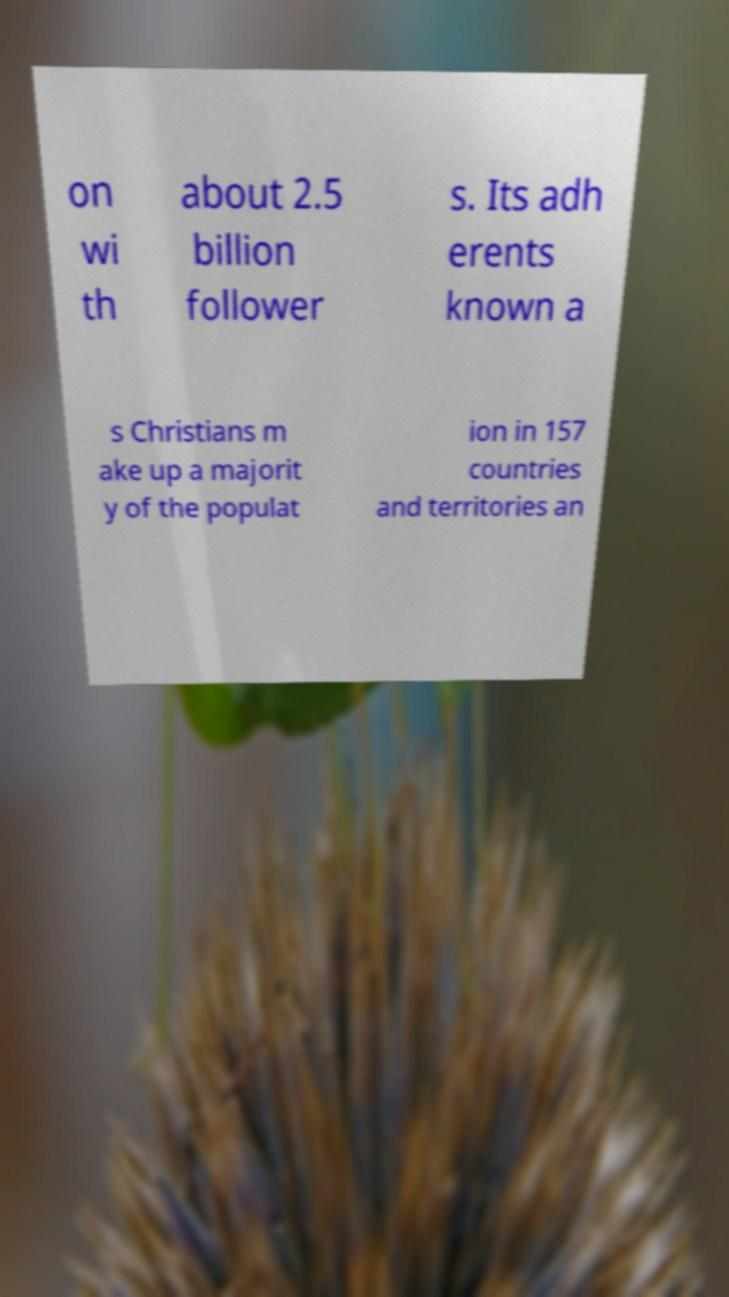Could you extract and type out the text from this image? on wi th about 2.5 billion follower s. Its adh erents known a s Christians m ake up a majorit y of the populat ion in 157 countries and territories an 